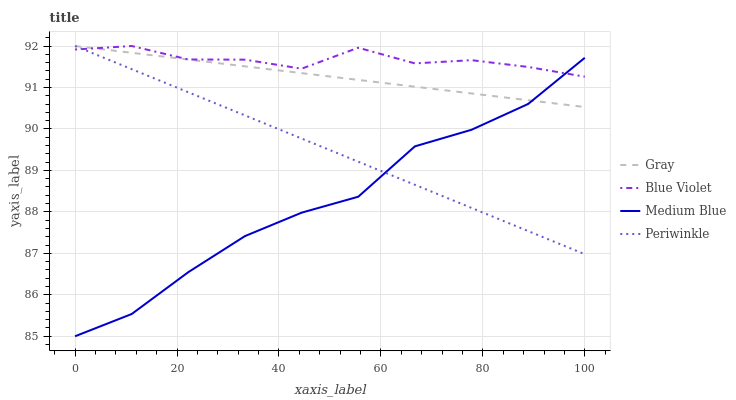Does Medium Blue have the minimum area under the curve?
Answer yes or no. Yes. Does Blue Violet have the maximum area under the curve?
Answer yes or no. Yes. Does Periwinkle have the minimum area under the curve?
Answer yes or no. No. Does Periwinkle have the maximum area under the curve?
Answer yes or no. No. Is Periwinkle the smoothest?
Answer yes or no. Yes. Is Medium Blue the roughest?
Answer yes or no. Yes. Is Medium Blue the smoothest?
Answer yes or no. No. Is Periwinkle the roughest?
Answer yes or no. No. Does Medium Blue have the lowest value?
Answer yes or no. Yes. Does Periwinkle have the lowest value?
Answer yes or no. No. Does Blue Violet have the highest value?
Answer yes or no. Yes. Does Medium Blue have the highest value?
Answer yes or no. No. Does Gray intersect Medium Blue?
Answer yes or no. Yes. Is Gray less than Medium Blue?
Answer yes or no. No. Is Gray greater than Medium Blue?
Answer yes or no. No. 